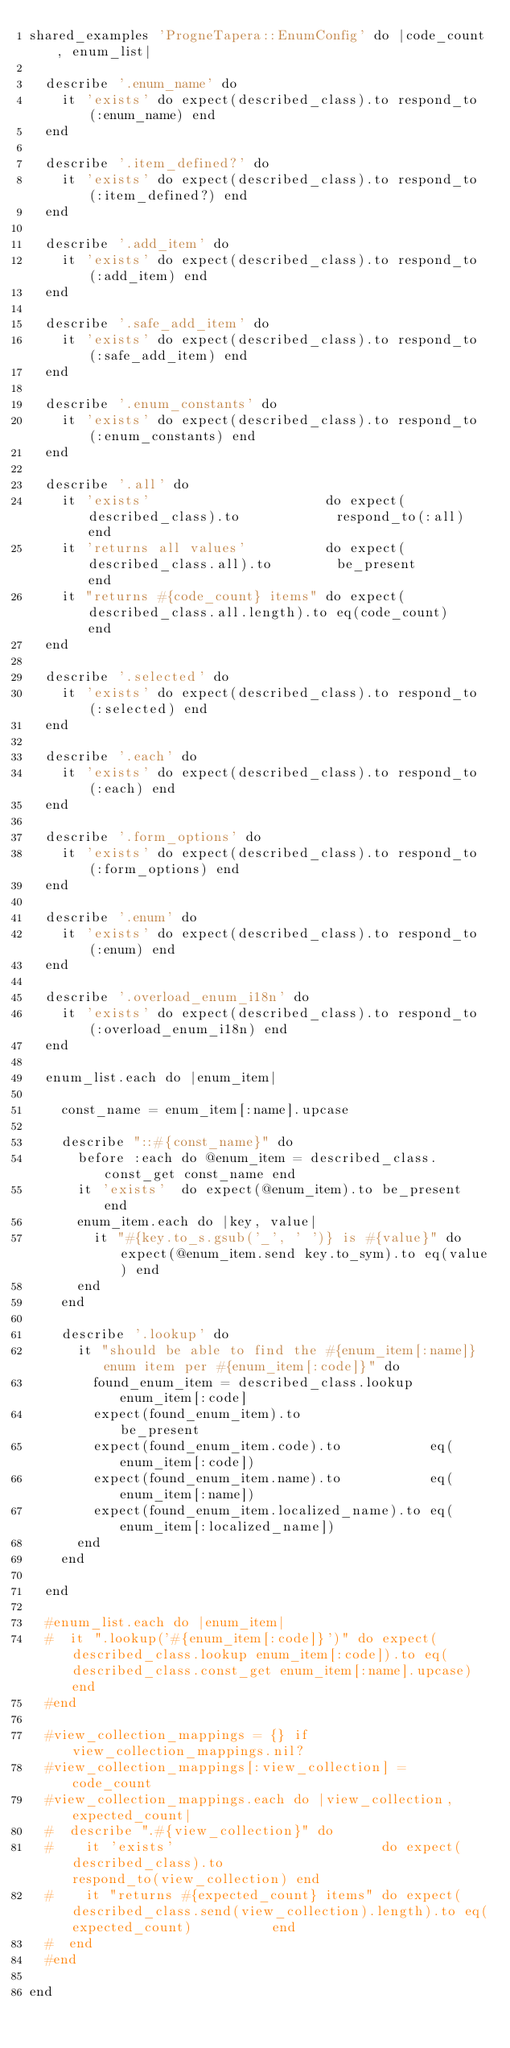<code> <loc_0><loc_0><loc_500><loc_500><_Ruby_>shared_examples 'ProgneTapera::EnumConfig' do |code_count, enum_list|

  describe '.enum_name' do
    it 'exists' do expect(described_class).to respond_to(:enum_name) end
  end

  describe '.item_defined?' do
    it 'exists' do expect(described_class).to respond_to(:item_defined?) end
  end

  describe '.add_item' do
    it 'exists' do expect(described_class).to respond_to(:add_item) end
  end

  describe '.safe_add_item' do
    it 'exists' do expect(described_class).to respond_to(:safe_add_item) end
  end

  describe '.enum_constants' do
    it 'exists' do expect(described_class).to respond_to(:enum_constants) end
  end

  describe '.all' do
    it 'exists'                      do expect(described_class).to            respond_to(:all) end
    it 'returns all values'          do expect(described_class.all).to        be_present       end
    it "returns #{code_count} items" do expect(described_class.all.length).to eq(code_count)   end
  end

  describe '.selected' do
    it 'exists' do expect(described_class).to respond_to(:selected) end
  end

  describe '.each' do
    it 'exists' do expect(described_class).to respond_to(:each) end
  end

  describe '.form_options' do
    it 'exists' do expect(described_class).to respond_to(:form_options) end
  end

  describe '.enum' do
    it 'exists' do expect(described_class).to respond_to(:enum) end
  end

  describe '.overload_enum_i18n' do
    it 'exists' do expect(described_class).to respond_to(:overload_enum_i18n) end
  end

  enum_list.each do |enum_item|

    const_name = enum_item[:name].upcase

    describe "::#{const_name}" do
      before :each do @enum_item = described_class.const_get const_name end
      it 'exists'  do expect(@enum_item).to be_present end
      enum_item.each do |key, value|
        it "#{key.to_s.gsub('_', ' ')} is #{value}" do expect(@enum_item.send key.to_sym).to eq(value) end
      end
    end

    describe '.lookup' do
      it "should be able to find the #{enum_item[:name]} enum item per #{enum_item[:code]}" do
        found_enum_item = described_class.lookup enum_item[:code]
        expect(found_enum_item).to                be_present
        expect(found_enum_item.code).to           eq(enum_item[:code])
        expect(found_enum_item.name).to           eq(enum_item[:name])
        expect(found_enum_item.localized_name).to eq(enum_item[:localized_name])
      end
    end

  end

  #enum_list.each do |enum_item|
  #  it ".lookup('#{enum_item[:code]}')" do expect(described_class.lookup enum_item[:code]).to eq(described_class.const_get enum_item[:name].upcase) end
  #end

  #view_collection_mappings = {} if view_collection_mappings.nil?
  #view_collection_mappings[:view_collection] = code_count
  #view_collection_mappings.each do |view_collection, expected_count|
  #  describe ".#{view_collection}" do
  #    it 'exists'                          do expect(described_class).to                              respond_to(view_collection) end
  #    it "returns #{expected_count} items" do expect(described_class.send(view_collection).length).to eq(expected_count)          end
  #  end
  #end

end
</code> 